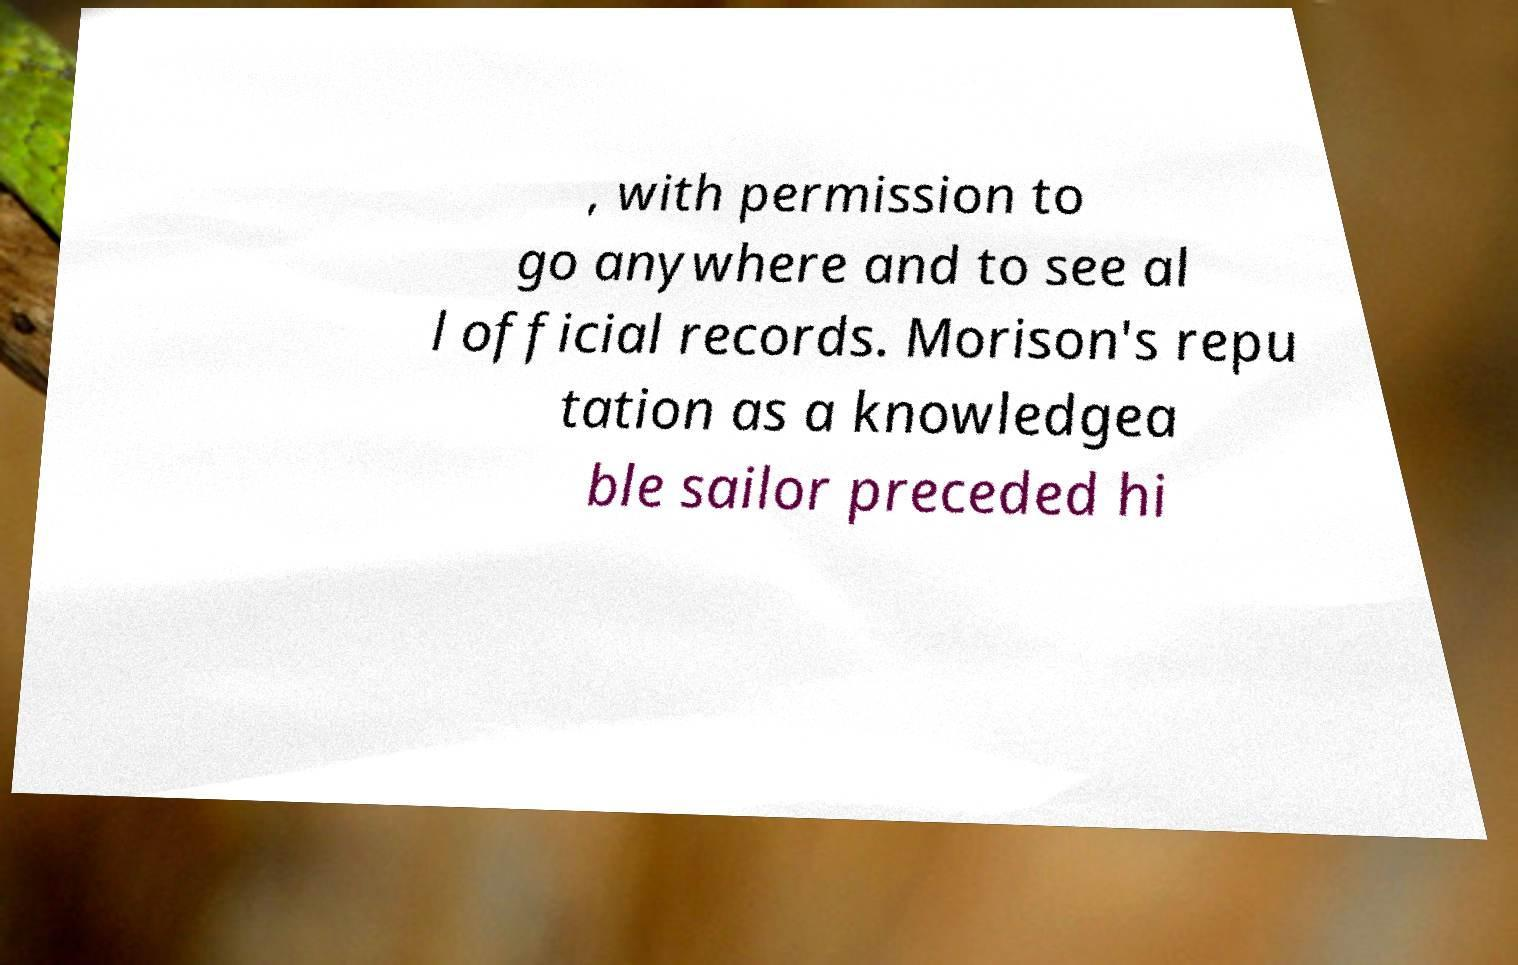Please read and relay the text visible in this image. What does it say? , with permission to go anywhere and to see al l official records. Morison's repu tation as a knowledgea ble sailor preceded hi 